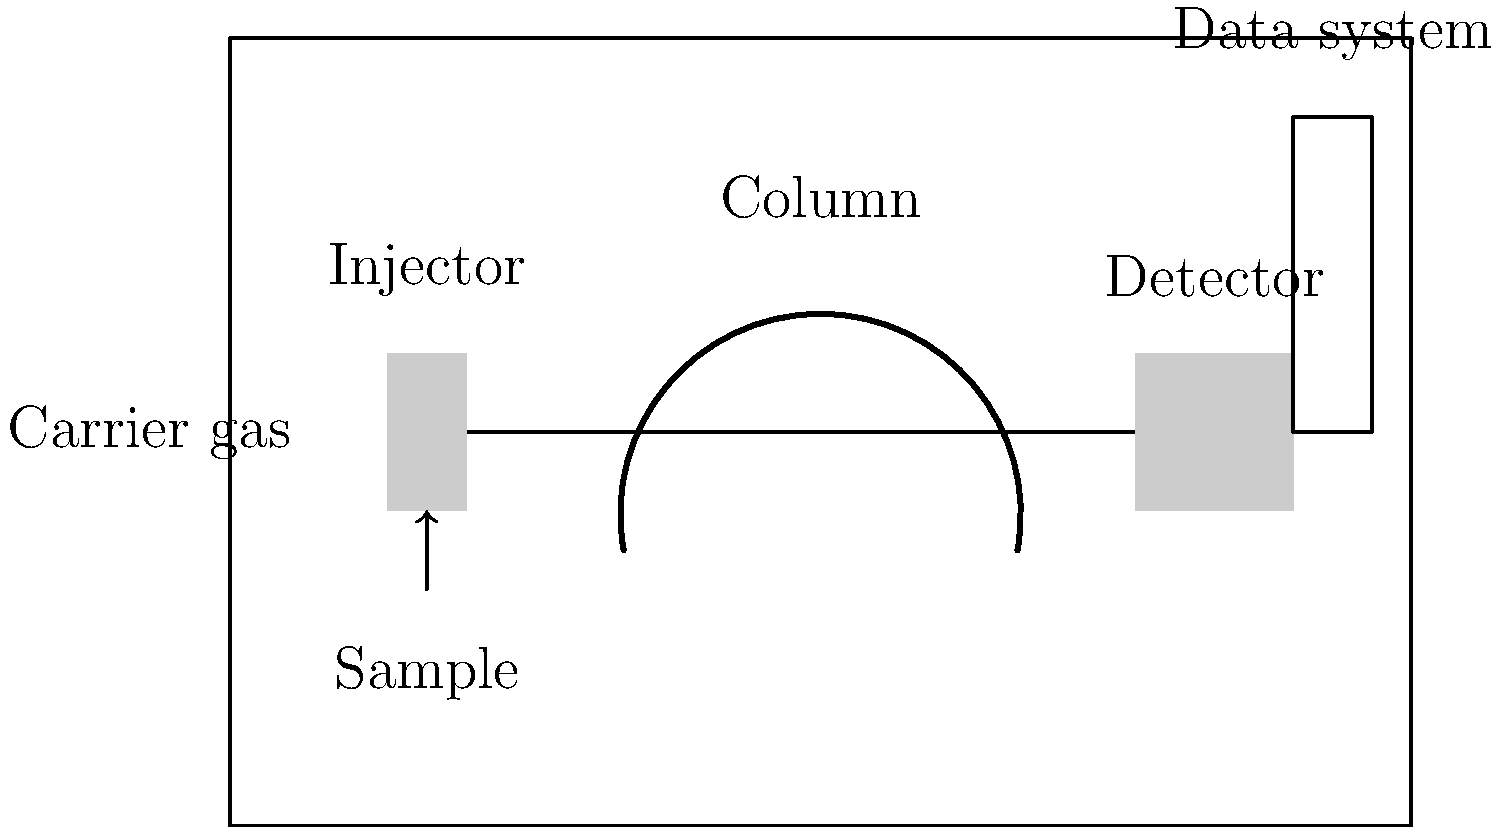In the given schematic diagram of a gas chromatography system, what is the primary function of the component labeled "Column"? To answer this question, let's break down the key components and their functions in a gas chromatography system:

1. Injector: This is where the sample is introduced into the system. It vaporizes the sample and mixes it with the carrier gas.

2. Carrier gas: This is an inert gas (often helium or nitrogen) that carries the sample through the system.

3. Column: This is the central component of the gas chromatography system. Its primary function is to separate the components of the sample. The column is typically a long, coiled tube with a stationary phase coating on the inside.

4. Detector: This component identifies and quantifies the separated components as they exit the column.

5. Data system: This records and processes the signals from the detector, producing a chromatogram.

The column's function in separating the sample components works as follows:

a) The vaporized sample, mixed with the carrier gas, enters the column.
b) Different components of the sample interact differently with the stationary phase in the column.
c) This difference in interaction causes some components to move through the column faster than others.
d) As a result, the components exit the column at different times, effectively separating them.

The separation occurs due to factors such as the chemical properties of the sample components, the type of stationary phase, column temperature, and flow rate of the carrier gas.

Therefore, the primary function of the column in a gas chromatography system is to separate the components of the sample mixture.
Answer: Separation of sample components 